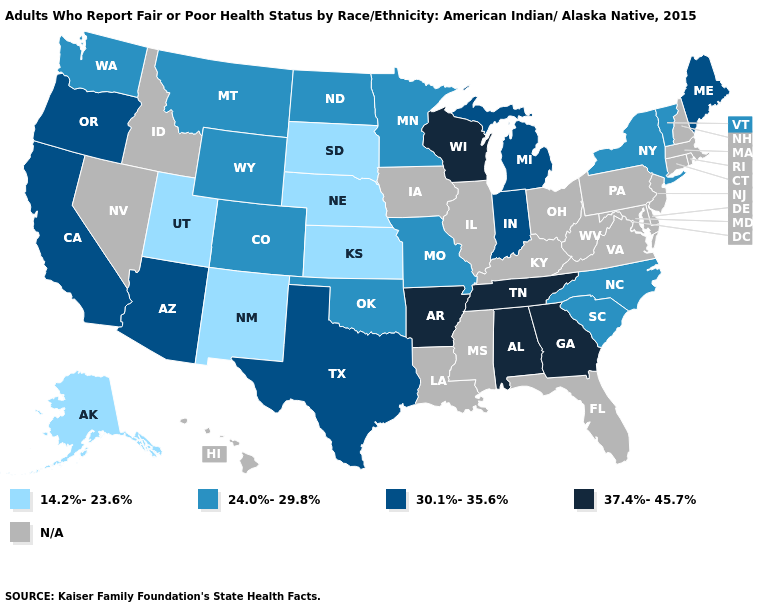What is the value of Nebraska?
Write a very short answer. 14.2%-23.6%. Among the states that border Washington , which have the highest value?
Concise answer only. Oregon. Which states have the lowest value in the Northeast?
Short answer required. New York, Vermont. Among the states that border North Dakota , which have the lowest value?
Give a very brief answer. South Dakota. Name the states that have a value in the range N/A?
Concise answer only. Connecticut, Delaware, Florida, Hawaii, Idaho, Illinois, Iowa, Kentucky, Louisiana, Maryland, Massachusetts, Mississippi, Nevada, New Hampshire, New Jersey, Ohio, Pennsylvania, Rhode Island, Virginia, West Virginia. What is the value of Tennessee?
Quick response, please. 37.4%-45.7%. Name the states that have a value in the range 24.0%-29.8%?
Write a very short answer. Colorado, Minnesota, Missouri, Montana, New York, North Carolina, North Dakota, Oklahoma, South Carolina, Vermont, Washington, Wyoming. Name the states that have a value in the range 30.1%-35.6%?
Keep it brief. Arizona, California, Indiana, Maine, Michigan, Oregon, Texas. Among the states that border Kentucky , which have the lowest value?
Keep it brief. Missouri. Which states have the lowest value in the USA?
Short answer required. Alaska, Kansas, Nebraska, New Mexico, South Dakota, Utah. What is the lowest value in the USA?
Give a very brief answer. 14.2%-23.6%. What is the value of Indiana?
Be succinct. 30.1%-35.6%. What is the lowest value in the South?
Give a very brief answer. 24.0%-29.8%. 